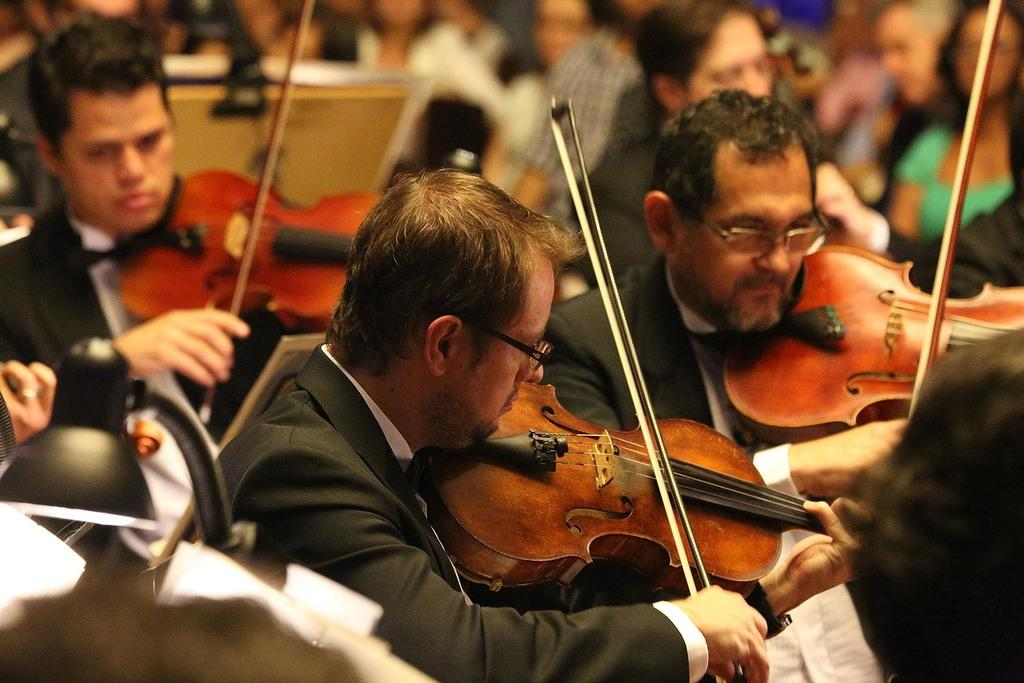Who or what is present in the image? There are people in the image. What are the people doing in the image? The people are playing violins. How are the violins being used in the image? The violins are being held in the hands of the people. What type of attraction can be seen in the background of the image? There is no background or attraction visible in the image; it only features people playing violins. 